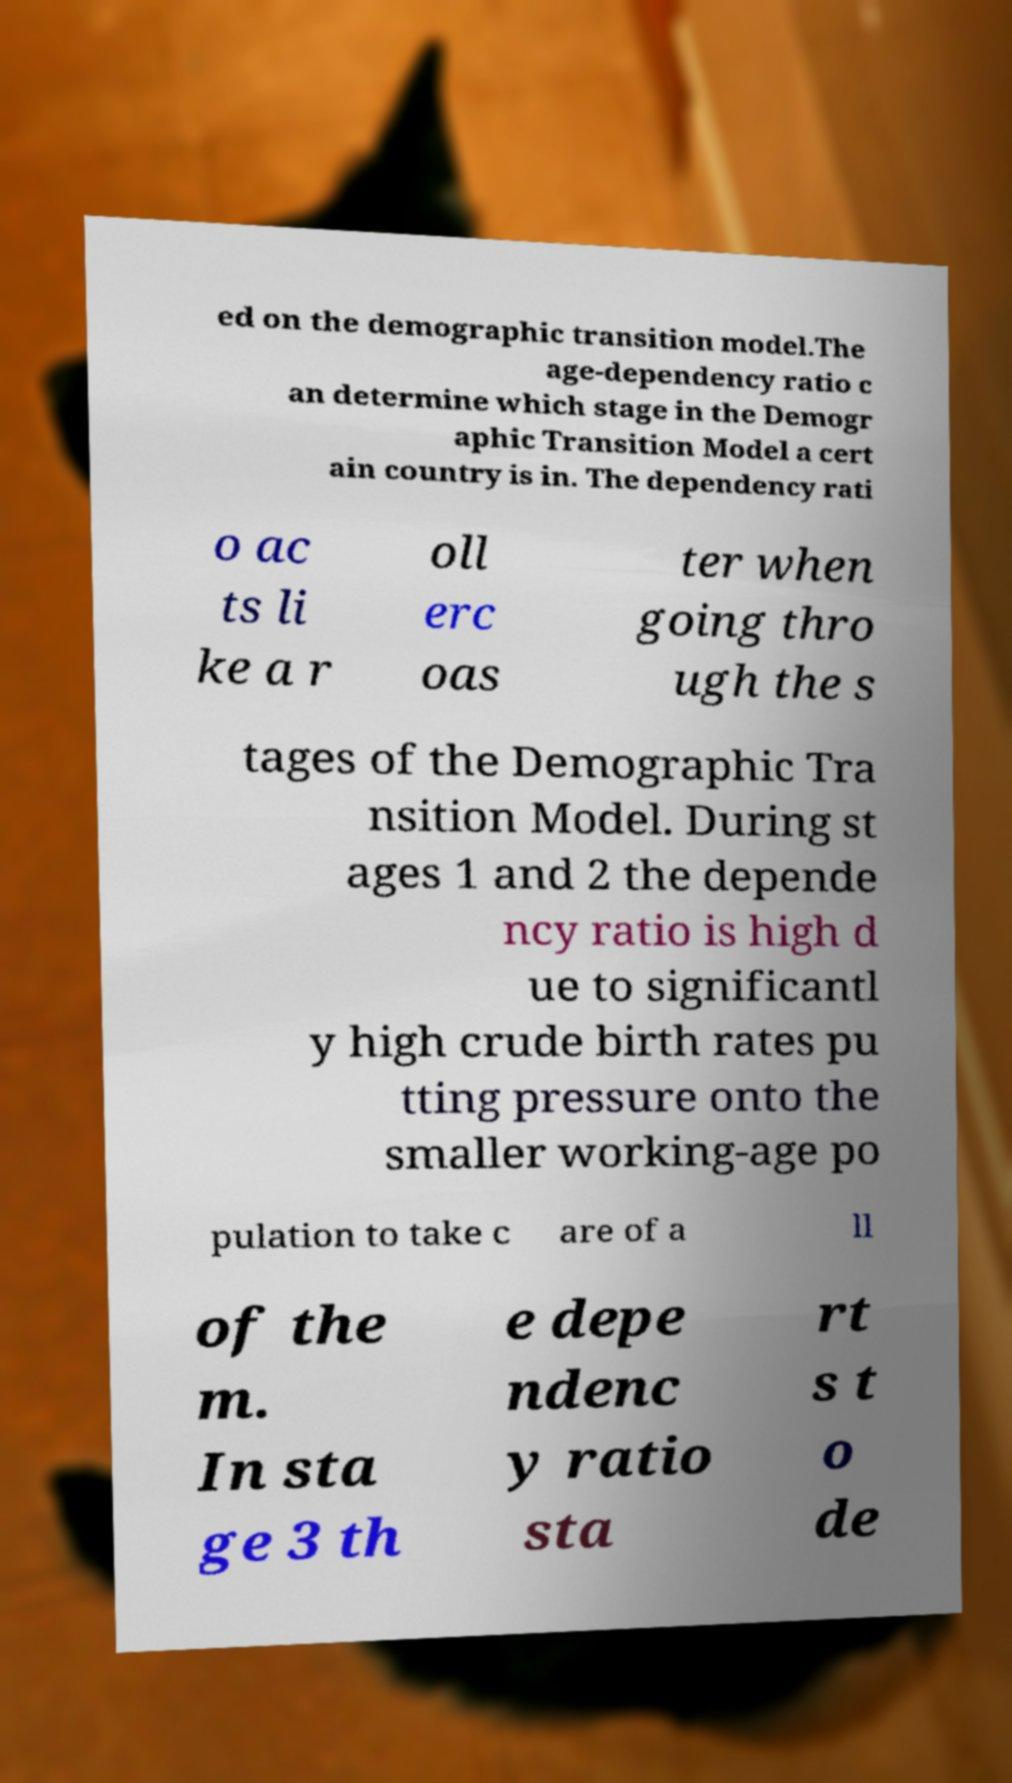What messages or text are displayed in this image? I need them in a readable, typed format. ed on the demographic transition model.The age-dependency ratio c an determine which stage in the Demogr aphic Transition Model a cert ain country is in. The dependency rati o ac ts li ke a r oll erc oas ter when going thro ugh the s tages of the Demographic Tra nsition Model. During st ages 1 and 2 the depende ncy ratio is high d ue to significantl y high crude birth rates pu tting pressure onto the smaller working-age po pulation to take c are of a ll of the m. In sta ge 3 th e depe ndenc y ratio sta rt s t o de 